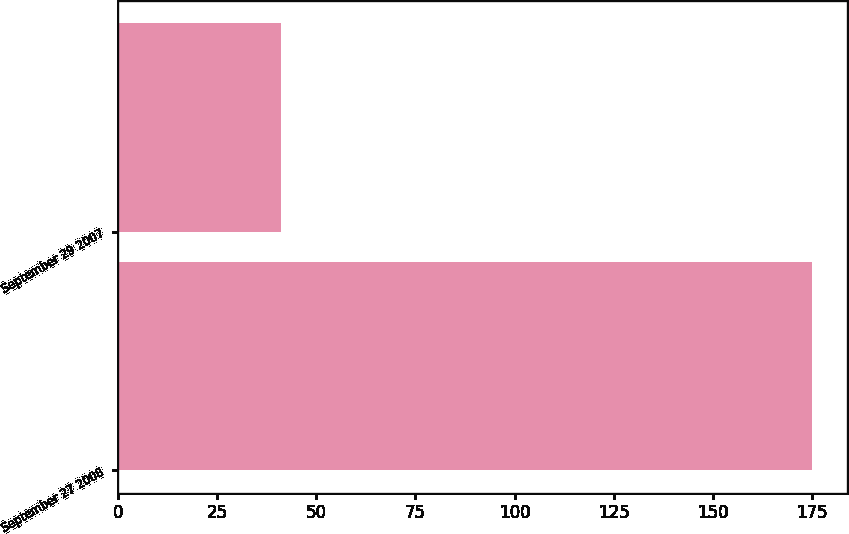Convert chart. <chart><loc_0><loc_0><loc_500><loc_500><bar_chart><fcel>September 27 2008<fcel>September 29 2007<nl><fcel>175<fcel>41<nl></chart> 